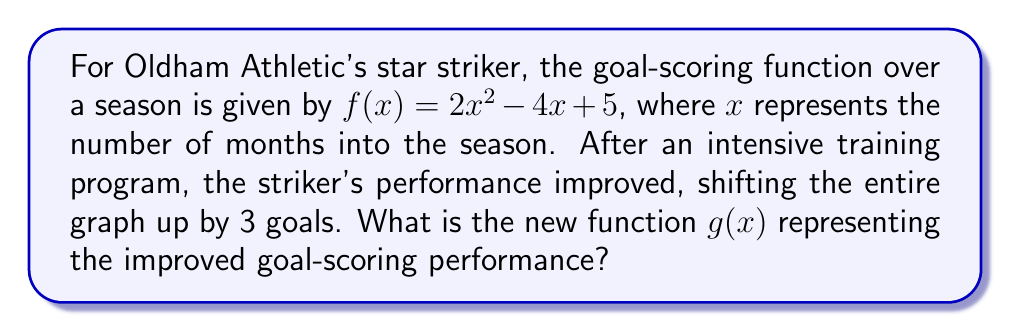Can you solve this math problem? To solve this problem, we need to understand vertical shifts in functions:

1) A vertical shift of a function $f(x)$ by $k$ units upward is represented by adding $k$ to the function:

   $g(x) = f(x) + k$

2) In this case, the original function is $f(x) = 2x^2 - 4x + 5$, and the shift is 3 units upward.

3) Therefore, we add 3 to the original function:

   $g(x) = f(x) + 3$
   $g(x) = (2x^2 - 4x + 5) + 3$

4) Simplifying:

   $g(x) = 2x^2 - 4x + 8$

This new function $g(x)$ represents the striker's improved goal-scoring performance, shifted up by 3 goals at every point compared to the original function.
Answer: $g(x) = 2x^2 - 4x + 8$ 